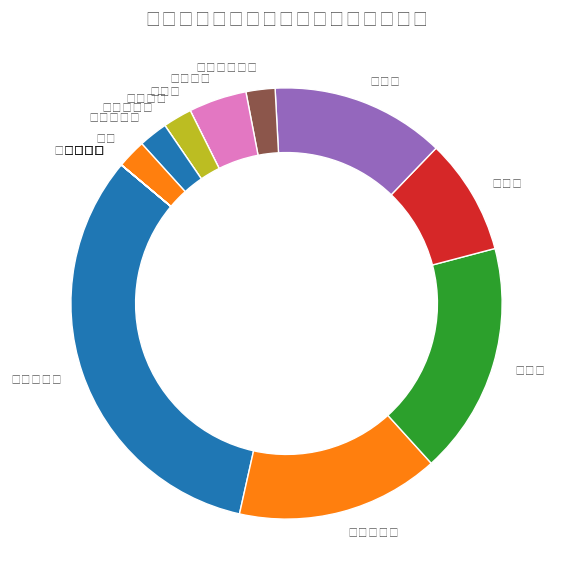曼彻斯特城占所有奖杯的比例是多少？ 看图表中曼彻斯特城的扇形部分，并查找其百分比标签。根据图表，曼彻斯特城赢得的奖杯数是15，占总体的最大比例。
Answer: 47.2% 哪个球队在过去十年中赢得的主要奖杯数量最少？ 看图表中所有占比最小或为零的扇形部分，这些球队包括埃弗顿、西汉姆联、纽卡斯尔联等，因为这些球队的扇形部分面积较小或者根本没有。
Answer: 埃弗顿、纽卡斯尔联及其他无奖杯的球队 曼彻斯特城和曼彻斯特联赢得的奖杯比例相差多少？ 看图表分别找到曼彻斯特城和曼彻斯特联的比例，通过从曼城的比例减去曼联的比例得出相差。根据图表，曼彻斯特城占47.2%，曼彻斯特联占22.0%，所以差异是47.2% - 22.0%。
Answer: 25.2% 除了曼彻斯特城之外，赢得奖杯数量最多的三个球队分别是谁？ 看图表找到最大的几个扇形部分（除曼彻斯特城外），分别查找其名称。在图表中，这些球队是切尔西、曼彻斯特联和阿森纳。
Answer: 切尔西、曼彻斯特联、阿森纳 埃弗顿、纽卡斯尔联和阿斯顿维拉的总奖杯比例是多少？ 分别在图表中找到埃弗顿、纽卡斯尔联和阿斯顿维拉的比例，把这三者的百分比加起来。根据图表显示，埃弗顿和纽卡斯尔联都是0%，阿斯顿维拉是3.1%，所以总和是0% + 0% + 3.1%。
Answer: 3.1% 曼彻斯特城的奖杯数量超过切尔西多少？ 首先找到曼彻斯特城和切尔西的奖杯数量（曼城是15，切尔西是8），然后通过相减得出差值。
Answer: 7 利物浦和托特纳姆热刺的奖杯数量之和是多少？ 查看图表中利物浦和托特纳姆热刺的奖杯数量，分别是6和1，然后将这两个数量相加。
Answer: 7 参与图表中的球队中，有多少支球队没有赢得任何奖杯？ 查看图表中占比为零的球队数量（无奖杯）。根据图表显示，有12支球队没有任何奖杯。
Answer: 12 赢得奖杯比例排在前三名的球队占整个奖杯的百分比是多少？ 查看图表中占比前三的扇形部分（曼彻斯特城、曼彻斯特联、切尔西），然后将这些百分比相加起来。曼彻斯特城是47.2%，曼彻斯特联是22.0%，切尔西是25.0%，所以总和是47.2% + 22.0% + 25.0%。
Answer: 94.2% 托特纳姆热刺和狼队赢得奖杯数的比例是否相等？ 查看图表中托特纳姆热刺和狼队的各自比例，比较它们的数值是否一致。托特纳姆热刺和狼队的比例分别是3.1%。
Answer: 是 